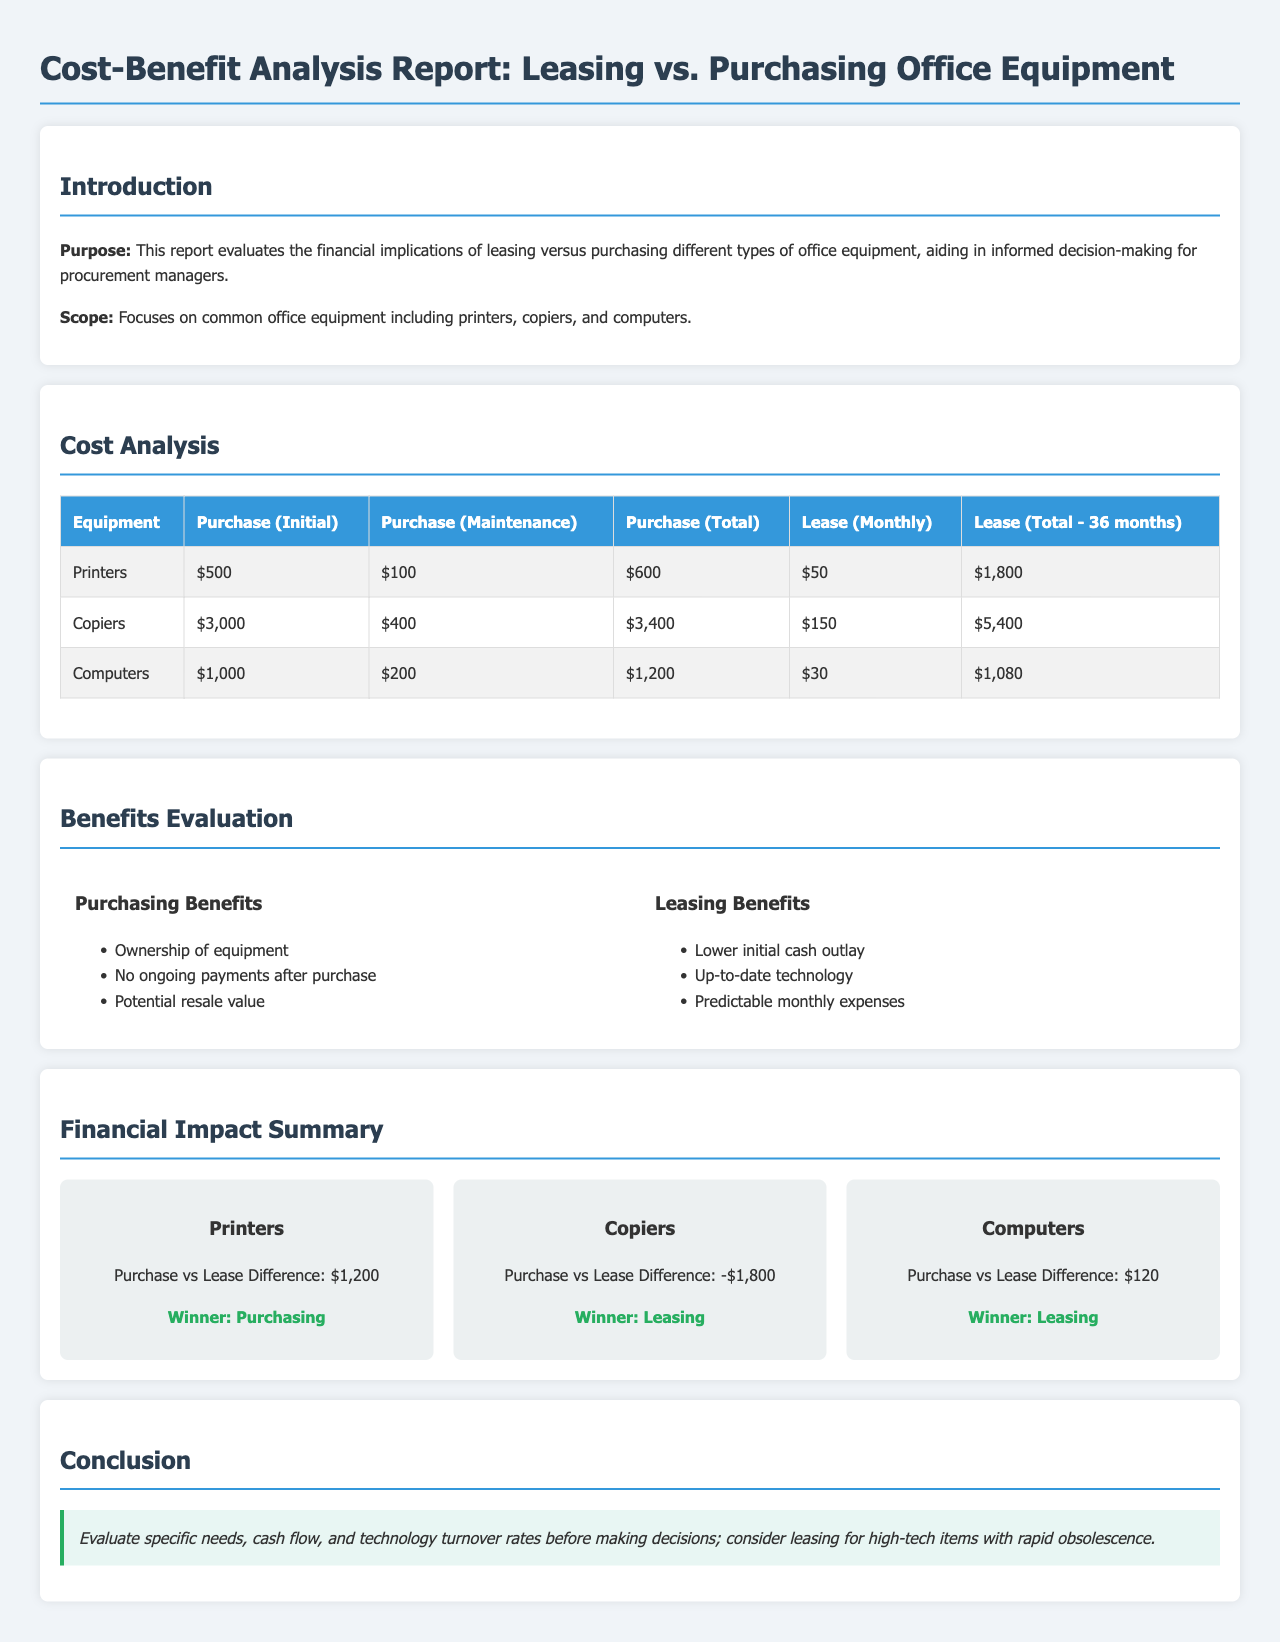What is the initial purchase cost of printers? The initial purchase cost of printers is stated in the cost analysis table.
Answer: $500 What is the total lease cost for copiers over 36 months? The total lease cost for copiers over 36 months is provided in the cost analysis table.
Answer: $5,400 Which equipment has a purchasing benefit of "Ownership of equipment"? This benefit is listed under the purchasing benefits in the benefits evaluation section.
Answer: Printers, Copiers, Computers What is the difference in financial impact for computers between purchasing and leasing? The difference is shown in the financial impact summary section.
Answer: $120 What is a leasing benefit related to expenses? The leasing benefits section provides various advantages, one of which relates to expenses.
Answer: Predictable monthly expenses Which equipment has purchasing as the winner? The financial impact summary shows which equipment favors purchasing.
Answer: Printers What is the maintenance cost for copiers when purchasing? The maintenance cost for copiers is found in the cost analysis table.
Answer: $400 What is the total purchase cost for computers including maintenance? The total purchase cost including maintenance is calculated and shown in the cost analysis table.
Answer: $1,200 Which type of equipment is recommended for leasing due to rapid obsolescence? The conclusion advises on the types of equipment to consider leasing based on technology turnover.
Answer: High-tech items 